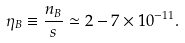<formula> <loc_0><loc_0><loc_500><loc_500>\eta _ { B } \equiv \frac { n _ { B } } { s } \simeq 2 - 7 \times 1 0 ^ { - 1 1 } .</formula> 